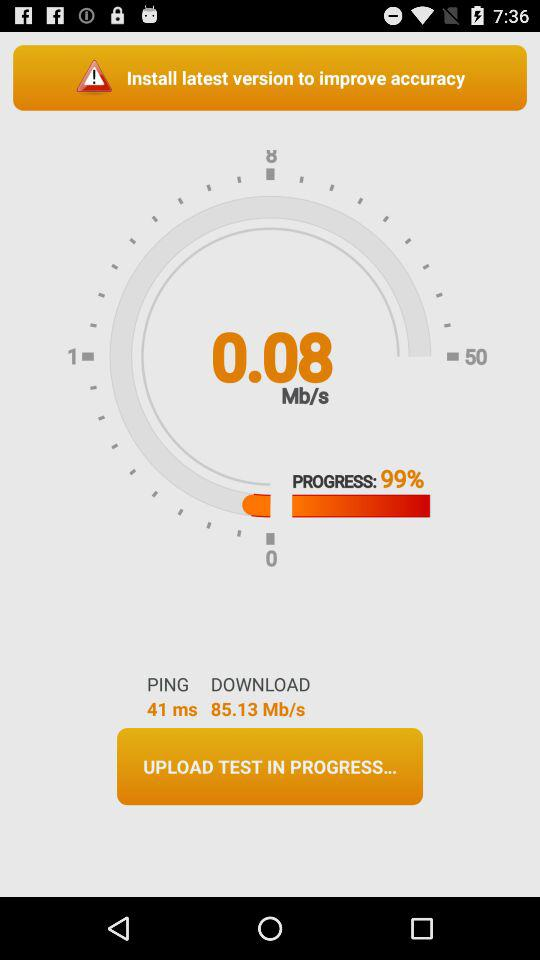What's the speed of the internet? The speed is 0.08 Mb/s. 